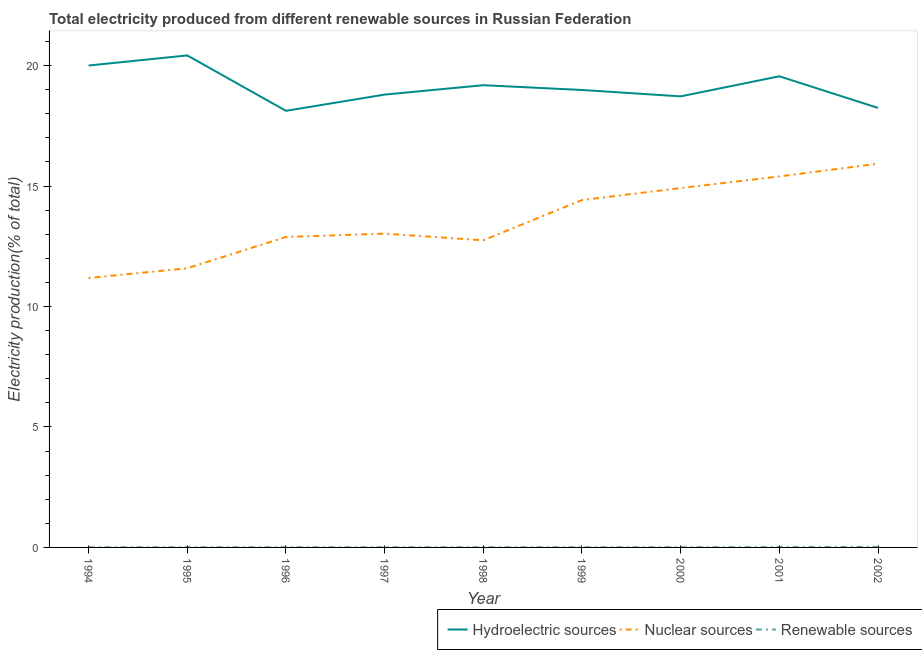How many different coloured lines are there?
Make the answer very short. 3. What is the percentage of electricity produced by nuclear sources in 1995?
Keep it short and to the point. 11.59. Across all years, what is the maximum percentage of electricity produced by renewable sources?
Provide a short and direct response. 0.02. Across all years, what is the minimum percentage of electricity produced by hydroelectric sources?
Your answer should be very brief. 18.12. In which year was the percentage of electricity produced by renewable sources maximum?
Your response must be concise. 2002. What is the total percentage of electricity produced by nuclear sources in the graph?
Keep it short and to the point. 122.08. What is the difference between the percentage of electricity produced by nuclear sources in 1998 and that in 1999?
Provide a short and direct response. -1.67. What is the difference between the percentage of electricity produced by renewable sources in 1995 and the percentage of electricity produced by nuclear sources in 2001?
Make the answer very short. -15.39. What is the average percentage of electricity produced by hydroelectric sources per year?
Make the answer very short. 19.11. In the year 1996, what is the difference between the percentage of electricity produced by renewable sources and percentage of electricity produced by nuclear sources?
Your response must be concise. -12.88. In how many years, is the percentage of electricity produced by renewable sources greater than 14 %?
Ensure brevity in your answer.  0. What is the ratio of the percentage of electricity produced by renewable sources in 1994 to that in 1996?
Your response must be concise. 1.04. What is the difference between the highest and the second highest percentage of electricity produced by nuclear sources?
Provide a short and direct response. 0.53. What is the difference between the highest and the lowest percentage of electricity produced by nuclear sources?
Offer a very short reply. 4.74. In how many years, is the percentage of electricity produced by renewable sources greater than the average percentage of electricity produced by renewable sources taken over all years?
Provide a succinct answer. 3. Is the sum of the percentage of electricity produced by renewable sources in 1996 and 2001 greater than the maximum percentage of electricity produced by nuclear sources across all years?
Give a very brief answer. No. Is the percentage of electricity produced by nuclear sources strictly greater than the percentage of electricity produced by renewable sources over the years?
Your response must be concise. Yes. How many lines are there?
Offer a terse response. 3. What is the difference between two consecutive major ticks on the Y-axis?
Your answer should be very brief. 5. Are the values on the major ticks of Y-axis written in scientific E-notation?
Provide a short and direct response. No. Does the graph contain any zero values?
Provide a succinct answer. No. How many legend labels are there?
Ensure brevity in your answer.  3. How are the legend labels stacked?
Your response must be concise. Horizontal. What is the title of the graph?
Keep it short and to the point. Total electricity produced from different renewable sources in Russian Federation. Does "Ages 20-50" appear as one of the legend labels in the graph?
Ensure brevity in your answer.  No. What is the Electricity production(% of total) of Hydroelectric sources in 1994?
Make the answer very short. 20. What is the Electricity production(% of total) of Nuclear sources in 1994?
Keep it short and to the point. 11.18. What is the Electricity production(% of total) in Renewable sources in 1994?
Your answer should be very brief. 0.01. What is the Electricity production(% of total) in Hydroelectric sources in 1995?
Provide a short and direct response. 20.42. What is the Electricity production(% of total) in Nuclear sources in 1995?
Offer a very short reply. 11.59. What is the Electricity production(% of total) of Renewable sources in 1995?
Keep it short and to the point. 0.01. What is the Electricity production(% of total) of Hydroelectric sources in 1996?
Keep it short and to the point. 18.12. What is the Electricity production(% of total) in Nuclear sources in 1996?
Your answer should be very brief. 12.88. What is the Electricity production(% of total) of Renewable sources in 1996?
Keep it short and to the point. 0.01. What is the Electricity production(% of total) in Hydroelectric sources in 1997?
Your answer should be very brief. 18.79. What is the Electricity production(% of total) in Nuclear sources in 1997?
Ensure brevity in your answer.  13.02. What is the Electricity production(% of total) in Renewable sources in 1997?
Provide a short and direct response. 0.01. What is the Electricity production(% of total) of Hydroelectric sources in 1998?
Ensure brevity in your answer.  19.18. What is the Electricity production(% of total) of Nuclear sources in 1998?
Your answer should be very brief. 12.75. What is the Electricity production(% of total) in Renewable sources in 1998?
Your answer should be very brief. 0.01. What is the Electricity production(% of total) of Hydroelectric sources in 1999?
Your response must be concise. 18.99. What is the Electricity production(% of total) in Nuclear sources in 1999?
Provide a succinct answer. 14.42. What is the Electricity production(% of total) in Renewable sources in 1999?
Offer a very short reply. 0.01. What is the Electricity production(% of total) in Hydroelectric sources in 2000?
Offer a terse response. 18.72. What is the Electricity production(% of total) of Nuclear sources in 2000?
Make the answer very short. 14.91. What is the Electricity production(% of total) in Renewable sources in 2000?
Give a very brief answer. 0.01. What is the Electricity production(% of total) in Hydroelectric sources in 2001?
Offer a very short reply. 19.55. What is the Electricity production(% of total) of Nuclear sources in 2001?
Offer a very short reply. 15.4. What is the Electricity production(% of total) of Renewable sources in 2001?
Give a very brief answer. 0.01. What is the Electricity production(% of total) in Hydroelectric sources in 2002?
Ensure brevity in your answer.  18.24. What is the Electricity production(% of total) in Nuclear sources in 2002?
Provide a short and direct response. 15.93. What is the Electricity production(% of total) of Renewable sources in 2002?
Offer a very short reply. 0.02. Across all years, what is the maximum Electricity production(% of total) in Hydroelectric sources?
Ensure brevity in your answer.  20.42. Across all years, what is the maximum Electricity production(% of total) of Nuclear sources?
Offer a terse response. 15.93. Across all years, what is the maximum Electricity production(% of total) in Renewable sources?
Keep it short and to the point. 0.02. Across all years, what is the minimum Electricity production(% of total) of Hydroelectric sources?
Keep it short and to the point. 18.12. Across all years, what is the minimum Electricity production(% of total) of Nuclear sources?
Your response must be concise. 11.18. Across all years, what is the minimum Electricity production(% of total) of Renewable sources?
Give a very brief answer. 0.01. What is the total Electricity production(% of total) of Hydroelectric sources in the graph?
Make the answer very short. 172.02. What is the total Electricity production(% of total) of Nuclear sources in the graph?
Your answer should be compact. 122.08. What is the total Electricity production(% of total) in Renewable sources in the graph?
Offer a terse response. 0.08. What is the difference between the Electricity production(% of total) in Hydroelectric sources in 1994 and that in 1995?
Provide a succinct answer. -0.42. What is the difference between the Electricity production(% of total) in Nuclear sources in 1994 and that in 1995?
Offer a very short reply. -0.41. What is the difference between the Electricity production(% of total) of Renewable sources in 1994 and that in 1995?
Your answer should be very brief. 0. What is the difference between the Electricity production(% of total) in Hydroelectric sources in 1994 and that in 1996?
Your response must be concise. 1.88. What is the difference between the Electricity production(% of total) of Nuclear sources in 1994 and that in 1996?
Ensure brevity in your answer.  -1.7. What is the difference between the Electricity production(% of total) of Renewable sources in 1994 and that in 1996?
Ensure brevity in your answer.  0. What is the difference between the Electricity production(% of total) in Hydroelectric sources in 1994 and that in 1997?
Provide a short and direct response. 1.21. What is the difference between the Electricity production(% of total) of Nuclear sources in 1994 and that in 1997?
Keep it short and to the point. -1.84. What is the difference between the Electricity production(% of total) of Hydroelectric sources in 1994 and that in 1998?
Keep it short and to the point. 0.82. What is the difference between the Electricity production(% of total) in Nuclear sources in 1994 and that in 1998?
Provide a succinct answer. -1.57. What is the difference between the Electricity production(% of total) of Renewable sources in 1994 and that in 1998?
Your answer should be very brief. -0. What is the difference between the Electricity production(% of total) of Hydroelectric sources in 1994 and that in 1999?
Your response must be concise. 1.01. What is the difference between the Electricity production(% of total) of Nuclear sources in 1994 and that in 1999?
Your answer should be compact. -3.24. What is the difference between the Electricity production(% of total) in Renewable sources in 1994 and that in 1999?
Your answer should be compact. -0. What is the difference between the Electricity production(% of total) in Hydroelectric sources in 1994 and that in 2000?
Your response must be concise. 1.28. What is the difference between the Electricity production(% of total) in Nuclear sources in 1994 and that in 2000?
Provide a succinct answer. -3.73. What is the difference between the Electricity production(% of total) in Renewable sources in 1994 and that in 2000?
Ensure brevity in your answer.  -0. What is the difference between the Electricity production(% of total) of Hydroelectric sources in 1994 and that in 2001?
Ensure brevity in your answer.  0.45. What is the difference between the Electricity production(% of total) of Nuclear sources in 1994 and that in 2001?
Offer a terse response. -4.22. What is the difference between the Electricity production(% of total) in Renewable sources in 1994 and that in 2001?
Provide a succinct answer. -0.01. What is the difference between the Electricity production(% of total) in Hydroelectric sources in 1994 and that in 2002?
Your answer should be very brief. 1.76. What is the difference between the Electricity production(% of total) of Nuclear sources in 1994 and that in 2002?
Offer a very short reply. -4.74. What is the difference between the Electricity production(% of total) of Renewable sources in 1994 and that in 2002?
Provide a succinct answer. -0.01. What is the difference between the Electricity production(% of total) of Hydroelectric sources in 1995 and that in 1996?
Offer a terse response. 2.3. What is the difference between the Electricity production(% of total) of Nuclear sources in 1995 and that in 1996?
Provide a short and direct response. -1.3. What is the difference between the Electricity production(% of total) of Renewable sources in 1995 and that in 1996?
Offer a very short reply. 0. What is the difference between the Electricity production(% of total) in Hydroelectric sources in 1995 and that in 1997?
Ensure brevity in your answer.  1.63. What is the difference between the Electricity production(% of total) in Nuclear sources in 1995 and that in 1997?
Provide a succinct answer. -1.44. What is the difference between the Electricity production(% of total) of Renewable sources in 1995 and that in 1997?
Give a very brief answer. 0. What is the difference between the Electricity production(% of total) of Hydroelectric sources in 1995 and that in 1998?
Your answer should be compact. 1.24. What is the difference between the Electricity production(% of total) of Nuclear sources in 1995 and that in 1998?
Offer a terse response. -1.16. What is the difference between the Electricity production(% of total) of Renewable sources in 1995 and that in 1998?
Provide a succinct answer. -0. What is the difference between the Electricity production(% of total) in Hydroelectric sources in 1995 and that in 1999?
Provide a succinct answer. 1.43. What is the difference between the Electricity production(% of total) in Nuclear sources in 1995 and that in 1999?
Your answer should be very brief. -2.83. What is the difference between the Electricity production(% of total) of Renewable sources in 1995 and that in 1999?
Provide a short and direct response. -0. What is the difference between the Electricity production(% of total) in Hydroelectric sources in 1995 and that in 2000?
Make the answer very short. 1.7. What is the difference between the Electricity production(% of total) in Nuclear sources in 1995 and that in 2000?
Ensure brevity in your answer.  -3.33. What is the difference between the Electricity production(% of total) of Renewable sources in 1995 and that in 2000?
Offer a terse response. -0. What is the difference between the Electricity production(% of total) in Hydroelectric sources in 1995 and that in 2001?
Make the answer very short. 0.87. What is the difference between the Electricity production(% of total) of Nuclear sources in 1995 and that in 2001?
Make the answer very short. -3.81. What is the difference between the Electricity production(% of total) of Renewable sources in 1995 and that in 2001?
Offer a terse response. -0.01. What is the difference between the Electricity production(% of total) in Hydroelectric sources in 1995 and that in 2002?
Provide a short and direct response. 2.18. What is the difference between the Electricity production(% of total) in Nuclear sources in 1995 and that in 2002?
Give a very brief answer. -4.34. What is the difference between the Electricity production(% of total) in Renewable sources in 1995 and that in 2002?
Ensure brevity in your answer.  -0.01. What is the difference between the Electricity production(% of total) in Hydroelectric sources in 1996 and that in 1997?
Provide a succinct answer. -0.67. What is the difference between the Electricity production(% of total) in Nuclear sources in 1996 and that in 1997?
Your answer should be very brief. -0.14. What is the difference between the Electricity production(% of total) in Renewable sources in 1996 and that in 1997?
Give a very brief answer. -0. What is the difference between the Electricity production(% of total) of Hydroelectric sources in 1996 and that in 1998?
Ensure brevity in your answer.  -1.06. What is the difference between the Electricity production(% of total) in Nuclear sources in 1996 and that in 1998?
Ensure brevity in your answer.  0.14. What is the difference between the Electricity production(% of total) of Renewable sources in 1996 and that in 1998?
Your response must be concise. -0. What is the difference between the Electricity production(% of total) of Hydroelectric sources in 1996 and that in 1999?
Provide a short and direct response. -0.86. What is the difference between the Electricity production(% of total) in Nuclear sources in 1996 and that in 1999?
Give a very brief answer. -1.53. What is the difference between the Electricity production(% of total) of Renewable sources in 1996 and that in 1999?
Provide a succinct answer. -0. What is the difference between the Electricity production(% of total) of Hydroelectric sources in 1996 and that in 2000?
Offer a very short reply. -0.6. What is the difference between the Electricity production(% of total) of Nuclear sources in 1996 and that in 2000?
Give a very brief answer. -2.03. What is the difference between the Electricity production(% of total) of Renewable sources in 1996 and that in 2000?
Offer a very short reply. -0. What is the difference between the Electricity production(% of total) in Hydroelectric sources in 1996 and that in 2001?
Make the answer very short. -1.43. What is the difference between the Electricity production(% of total) in Nuclear sources in 1996 and that in 2001?
Your answer should be compact. -2.51. What is the difference between the Electricity production(% of total) of Renewable sources in 1996 and that in 2001?
Your response must be concise. -0.01. What is the difference between the Electricity production(% of total) of Hydroelectric sources in 1996 and that in 2002?
Offer a very short reply. -0.12. What is the difference between the Electricity production(% of total) in Nuclear sources in 1996 and that in 2002?
Give a very brief answer. -3.04. What is the difference between the Electricity production(% of total) of Renewable sources in 1996 and that in 2002?
Make the answer very short. -0.01. What is the difference between the Electricity production(% of total) in Hydroelectric sources in 1997 and that in 1998?
Provide a short and direct response. -0.39. What is the difference between the Electricity production(% of total) in Nuclear sources in 1997 and that in 1998?
Make the answer very short. 0.27. What is the difference between the Electricity production(% of total) in Renewable sources in 1997 and that in 1998?
Provide a succinct answer. -0. What is the difference between the Electricity production(% of total) in Hydroelectric sources in 1997 and that in 1999?
Your answer should be very brief. -0.19. What is the difference between the Electricity production(% of total) in Nuclear sources in 1997 and that in 1999?
Provide a succinct answer. -1.39. What is the difference between the Electricity production(% of total) in Renewable sources in 1997 and that in 1999?
Make the answer very short. -0. What is the difference between the Electricity production(% of total) of Hydroelectric sources in 1997 and that in 2000?
Offer a terse response. 0.07. What is the difference between the Electricity production(% of total) in Nuclear sources in 1997 and that in 2000?
Provide a succinct answer. -1.89. What is the difference between the Electricity production(% of total) in Renewable sources in 1997 and that in 2000?
Your answer should be compact. -0. What is the difference between the Electricity production(% of total) of Hydroelectric sources in 1997 and that in 2001?
Offer a terse response. -0.76. What is the difference between the Electricity production(% of total) of Nuclear sources in 1997 and that in 2001?
Your response must be concise. -2.38. What is the difference between the Electricity production(% of total) in Renewable sources in 1997 and that in 2001?
Give a very brief answer. -0.01. What is the difference between the Electricity production(% of total) of Hydroelectric sources in 1997 and that in 2002?
Provide a succinct answer. 0.55. What is the difference between the Electricity production(% of total) in Nuclear sources in 1997 and that in 2002?
Give a very brief answer. -2.9. What is the difference between the Electricity production(% of total) of Renewable sources in 1997 and that in 2002?
Your response must be concise. -0.01. What is the difference between the Electricity production(% of total) in Hydroelectric sources in 1998 and that in 1999?
Provide a succinct answer. 0.2. What is the difference between the Electricity production(% of total) in Nuclear sources in 1998 and that in 1999?
Make the answer very short. -1.67. What is the difference between the Electricity production(% of total) in Renewable sources in 1998 and that in 1999?
Ensure brevity in your answer.  -0. What is the difference between the Electricity production(% of total) in Hydroelectric sources in 1998 and that in 2000?
Offer a very short reply. 0.46. What is the difference between the Electricity production(% of total) of Nuclear sources in 1998 and that in 2000?
Your answer should be compact. -2.17. What is the difference between the Electricity production(% of total) of Renewable sources in 1998 and that in 2000?
Keep it short and to the point. -0. What is the difference between the Electricity production(% of total) in Hydroelectric sources in 1998 and that in 2001?
Offer a very short reply. -0.37. What is the difference between the Electricity production(% of total) of Nuclear sources in 1998 and that in 2001?
Make the answer very short. -2.65. What is the difference between the Electricity production(% of total) in Renewable sources in 1998 and that in 2001?
Provide a succinct answer. -0.01. What is the difference between the Electricity production(% of total) of Hydroelectric sources in 1998 and that in 2002?
Keep it short and to the point. 0.94. What is the difference between the Electricity production(% of total) in Nuclear sources in 1998 and that in 2002?
Offer a terse response. -3.18. What is the difference between the Electricity production(% of total) of Renewable sources in 1998 and that in 2002?
Your answer should be compact. -0.01. What is the difference between the Electricity production(% of total) in Hydroelectric sources in 1999 and that in 2000?
Your answer should be compact. 0.27. What is the difference between the Electricity production(% of total) of Nuclear sources in 1999 and that in 2000?
Offer a very short reply. -0.5. What is the difference between the Electricity production(% of total) of Renewable sources in 1999 and that in 2000?
Give a very brief answer. -0. What is the difference between the Electricity production(% of total) in Hydroelectric sources in 1999 and that in 2001?
Make the answer very short. -0.57. What is the difference between the Electricity production(% of total) in Nuclear sources in 1999 and that in 2001?
Offer a very short reply. -0.98. What is the difference between the Electricity production(% of total) in Renewable sources in 1999 and that in 2001?
Your response must be concise. -0.01. What is the difference between the Electricity production(% of total) in Hydroelectric sources in 1999 and that in 2002?
Offer a terse response. 0.74. What is the difference between the Electricity production(% of total) of Nuclear sources in 1999 and that in 2002?
Ensure brevity in your answer.  -1.51. What is the difference between the Electricity production(% of total) of Renewable sources in 1999 and that in 2002?
Offer a terse response. -0.01. What is the difference between the Electricity production(% of total) in Hydroelectric sources in 2000 and that in 2001?
Offer a very short reply. -0.83. What is the difference between the Electricity production(% of total) of Nuclear sources in 2000 and that in 2001?
Offer a very short reply. -0.48. What is the difference between the Electricity production(% of total) of Renewable sources in 2000 and that in 2001?
Your answer should be very brief. -0. What is the difference between the Electricity production(% of total) in Hydroelectric sources in 2000 and that in 2002?
Give a very brief answer. 0.48. What is the difference between the Electricity production(% of total) of Nuclear sources in 2000 and that in 2002?
Offer a terse response. -1.01. What is the difference between the Electricity production(% of total) of Renewable sources in 2000 and that in 2002?
Give a very brief answer. -0.01. What is the difference between the Electricity production(% of total) of Hydroelectric sources in 2001 and that in 2002?
Keep it short and to the point. 1.31. What is the difference between the Electricity production(% of total) in Nuclear sources in 2001 and that in 2002?
Offer a very short reply. -0.53. What is the difference between the Electricity production(% of total) in Renewable sources in 2001 and that in 2002?
Make the answer very short. -0.01. What is the difference between the Electricity production(% of total) of Hydroelectric sources in 1994 and the Electricity production(% of total) of Nuclear sources in 1995?
Provide a short and direct response. 8.41. What is the difference between the Electricity production(% of total) in Hydroelectric sources in 1994 and the Electricity production(% of total) in Renewable sources in 1995?
Give a very brief answer. 19.99. What is the difference between the Electricity production(% of total) of Nuclear sources in 1994 and the Electricity production(% of total) of Renewable sources in 1995?
Your response must be concise. 11.17. What is the difference between the Electricity production(% of total) of Hydroelectric sources in 1994 and the Electricity production(% of total) of Nuclear sources in 1996?
Ensure brevity in your answer.  7.12. What is the difference between the Electricity production(% of total) of Hydroelectric sources in 1994 and the Electricity production(% of total) of Renewable sources in 1996?
Offer a very short reply. 19.99. What is the difference between the Electricity production(% of total) of Nuclear sources in 1994 and the Electricity production(% of total) of Renewable sources in 1996?
Your answer should be very brief. 11.17. What is the difference between the Electricity production(% of total) in Hydroelectric sources in 1994 and the Electricity production(% of total) in Nuclear sources in 1997?
Ensure brevity in your answer.  6.98. What is the difference between the Electricity production(% of total) of Hydroelectric sources in 1994 and the Electricity production(% of total) of Renewable sources in 1997?
Keep it short and to the point. 19.99. What is the difference between the Electricity production(% of total) of Nuclear sources in 1994 and the Electricity production(% of total) of Renewable sources in 1997?
Make the answer very short. 11.17. What is the difference between the Electricity production(% of total) of Hydroelectric sources in 1994 and the Electricity production(% of total) of Nuclear sources in 1998?
Offer a terse response. 7.25. What is the difference between the Electricity production(% of total) of Hydroelectric sources in 1994 and the Electricity production(% of total) of Renewable sources in 1998?
Provide a short and direct response. 19.99. What is the difference between the Electricity production(% of total) of Nuclear sources in 1994 and the Electricity production(% of total) of Renewable sources in 1998?
Ensure brevity in your answer.  11.17. What is the difference between the Electricity production(% of total) in Hydroelectric sources in 1994 and the Electricity production(% of total) in Nuclear sources in 1999?
Ensure brevity in your answer.  5.58. What is the difference between the Electricity production(% of total) of Hydroelectric sources in 1994 and the Electricity production(% of total) of Renewable sources in 1999?
Your answer should be compact. 19.99. What is the difference between the Electricity production(% of total) in Nuclear sources in 1994 and the Electricity production(% of total) in Renewable sources in 1999?
Ensure brevity in your answer.  11.17. What is the difference between the Electricity production(% of total) in Hydroelectric sources in 1994 and the Electricity production(% of total) in Nuclear sources in 2000?
Provide a succinct answer. 5.09. What is the difference between the Electricity production(% of total) in Hydroelectric sources in 1994 and the Electricity production(% of total) in Renewable sources in 2000?
Your response must be concise. 19.99. What is the difference between the Electricity production(% of total) of Nuclear sources in 1994 and the Electricity production(% of total) of Renewable sources in 2000?
Provide a succinct answer. 11.17. What is the difference between the Electricity production(% of total) of Hydroelectric sources in 1994 and the Electricity production(% of total) of Nuclear sources in 2001?
Offer a terse response. 4.6. What is the difference between the Electricity production(% of total) in Hydroelectric sources in 1994 and the Electricity production(% of total) in Renewable sources in 2001?
Your answer should be compact. 19.99. What is the difference between the Electricity production(% of total) in Nuclear sources in 1994 and the Electricity production(% of total) in Renewable sources in 2001?
Give a very brief answer. 11.17. What is the difference between the Electricity production(% of total) of Hydroelectric sources in 1994 and the Electricity production(% of total) of Nuclear sources in 2002?
Provide a succinct answer. 4.07. What is the difference between the Electricity production(% of total) in Hydroelectric sources in 1994 and the Electricity production(% of total) in Renewable sources in 2002?
Provide a short and direct response. 19.98. What is the difference between the Electricity production(% of total) of Nuclear sources in 1994 and the Electricity production(% of total) of Renewable sources in 2002?
Give a very brief answer. 11.16. What is the difference between the Electricity production(% of total) in Hydroelectric sources in 1995 and the Electricity production(% of total) in Nuclear sources in 1996?
Provide a short and direct response. 7.54. What is the difference between the Electricity production(% of total) in Hydroelectric sources in 1995 and the Electricity production(% of total) in Renewable sources in 1996?
Offer a very short reply. 20.41. What is the difference between the Electricity production(% of total) in Nuclear sources in 1995 and the Electricity production(% of total) in Renewable sources in 1996?
Offer a very short reply. 11.58. What is the difference between the Electricity production(% of total) in Hydroelectric sources in 1995 and the Electricity production(% of total) in Nuclear sources in 1997?
Your answer should be very brief. 7.4. What is the difference between the Electricity production(% of total) of Hydroelectric sources in 1995 and the Electricity production(% of total) of Renewable sources in 1997?
Provide a succinct answer. 20.41. What is the difference between the Electricity production(% of total) of Nuclear sources in 1995 and the Electricity production(% of total) of Renewable sources in 1997?
Your answer should be compact. 11.58. What is the difference between the Electricity production(% of total) of Hydroelectric sources in 1995 and the Electricity production(% of total) of Nuclear sources in 1998?
Provide a short and direct response. 7.67. What is the difference between the Electricity production(% of total) in Hydroelectric sources in 1995 and the Electricity production(% of total) in Renewable sources in 1998?
Provide a short and direct response. 20.41. What is the difference between the Electricity production(% of total) of Nuclear sources in 1995 and the Electricity production(% of total) of Renewable sources in 1998?
Ensure brevity in your answer.  11.58. What is the difference between the Electricity production(% of total) in Hydroelectric sources in 1995 and the Electricity production(% of total) in Nuclear sources in 1999?
Offer a terse response. 6. What is the difference between the Electricity production(% of total) in Hydroelectric sources in 1995 and the Electricity production(% of total) in Renewable sources in 1999?
Offer a very short reply. 20.41. What is the difference between the Electricity production(% of total) of Nuclear sources in 1995 and the Electricity production(% of total) of Renewable sources in 1999?
Keep it short and to the point. 11.58. What is the difference between the Electricity production(% of total) in Hydroelectric sources in 1995 and the Electricity production(% of total) in Nuclear sources in 2000?
Give a very brief answer. 5.51. What is the difference between the Electricity production(% of total) in Hydroelectric sources in 1995 and the Electricity production(% of total) in Renewable sources in 2000?
Offer a terse response. 20.41. What is the difference between the Electricity production(% of total) in Nuclear sources in 1995 and the Electricity production(% of total) in Renewable sources in 2000?
Ensure brevity in your answer.  11.58. What is the difference between the Electricity production(% of total) in Hydroelectric sources in 1995 and the Electricity production(% of total) in Nuclear sources in 2001?
Give a very brief answer. 5.02. What is the difference between the Electricity production(% of total) in Hydroelectric sources in 1995 and the Electricity production(% of total) in Renewable sources in 2001?
Offer a very short reply. 20.41. What is the difference between the Electricity production(% of total) in Nuclear sources in 1995 and the Electricity production(% of total) in Renewable sources in 2001?
Your answer should be compact. 11.57. What is the difference between the Electricity production(% of total) in Hydroelectric sources in 1995 and the Electricity production(% of total) in Nuclear sources in 2002?
Offer a terse response. 4.49. What is the difference between the Electricity production(% of total) of Hydroelectric sources in 1995 and the Electricity production(% of total) of Renewable sources in 2002?
Provide a short and direct response. 20.4. What is the difference between the Electricity production(% of total) in Nuclear sources in 1995 and the Electricity production(% of total) in Renewable sources in 2002?
Offer a terse response. 11.57. What is the difference between the Electricity production(% of total) in Hydroelectric sources in 1996 and the Electricity production(% of total) in Nuclear sources in 1997?
Your answer should be very brief. 5.1. What is the difference between the Electricity production(% of total) of Hydroelectric sources in 1996 and the Electricity production(% of total) of Renewable sources in 1997?
Keep it short and to the point. 18.11. What is the difference between the Electricity production(% of total) of Nuclear sources in 1996 and the Electricity production(% of total) of Renewable sources in 1997?
Your response must be concise. 12.88. What is the difference between the Electricity production(% of total) in Hydroelectric sources in 1996 and the Electricity production(% of total) in Nuclear sources in 1998?
Your answer should be very brief. 5.37. What is the difference between the Electricity production(% of total) of Hydroelectric sources in 1996 and the Electricity production(% of total) of Renewable sources in 1998?
Your response must be concise. 18.11. What is the difference between the Electricity production(% of total) in Nuclear sources in 1996 and the Electricity production(% of total) in Renewable sources in 1998?
Offer a very short reply. 12.88. What is the difference between the Electricity production(% of total) of Hydroelectric sources in 1996 and the Electricity production(% of total) of Nuclear sources in 1999?
Your response must be concise. 3.7. What is the difference between the Electricity production(% of total) of Hydroelectric sources in 1996 and the Electricity production(% of total) of Renewable sources in 1999?
Give a very brief answer. 18.11. What is the difference between the Electricity production(% of total) in Nuclear sources in 1996 and the Electricity production(% of total) in Renewable sources in 1999?
Keep it short and to the point. 12.88. What is the difference between the Electricity production(% of total) in Hydroelectric sources in 1996 and the Electricity production(% of total) in Nuclear sources in 2000?
Your response must be concise. 3.21. What is the difference between the Electricity production(% of total) in Hydroelectric sources in 1996 and the Electricity production(% of total) in Renewable sources in 2000?
Offer a terse response. 18.11. What is the difference between the Electricity production(% of total) of Nuclear sources in 1996 and the Electricity production(% of total) of Renewable sources in 2000?
Your answer should be very brief. 12.88. What is the difference between the Electricity production(% of total) of Hydroelectric sources in 1996 and the Electricity production(% of total) of Nuclear sources in 2001?
Your response must be concise. 2.72. What is the difference between the Electricity production(% of total) in Hydroelectric sources in 1996 and the Electricity production(% of total) in Renewable sources in 2001?
Give a very brief answer. 18.11. What is the difference between the Electricity production(% of total) in Nuclear sources in 1996 and the Electricity production(% of total) in Renewable sources in 2001?
Keep it short and to the point. 12.87. What is the difference between the Electricity production(% of total) in Hydroelectric sources in 1996 and the Electricity production(% of total) in Nuclear sources in 2002?
Give a very brief answer. 2.19. What is the difference between the Electricity production(% of total) in Hydroelectric sources in 1996 and the Electricity production(% of total) in Renewable sources in 2002?
Make the answer very short. 18.1. What is the difference between the Electricity production(% of total) in Nuclear sources in 1996 and the Electricity production(% of total) in Renewable sources in 2002?
Ensure brevity in your answer.  12.86. What is the difference between the Electricity production(% of total) in Hydroelectric sources in 1997 and the Electricity production(% of total) in Nuclear sources in 1998?
Your answer should be very brief. 6.05. What is the difference between the Electricity production(% of total) of Hydroelectric sources in 1997 and the Electricity production(% of total) of Renewable sources in 1998?
Offer a very short reply. 18.79. What is the difference between the Electricity production(% of total) in Nuclear sources in 1997 and the Electricity production(% of total) in Renewable sources in 1998?
Your response must be concise. 13.02. What is the difference between the Electricity production(% of total) in Hydroelectric sources in 1997 and the Electricity production(% of total) in Nuclear sources in 1999?
Provide a short and direct response. 4.38. What is the difference between the Electricity production(% of total) in Hydroelectric sources in 1997 and the Electricity production(% of total) in Renewable sources in 1999?
Your answer should be compact. 18.79. What is the difference between the Electricity production(% of total) of Nuclear sources in 1997 and the Electricity production(% of total) of Renewable sources in 1999?
Provide a succinct answer. 13.02. What is the difference between the Electricity production(% of total) in Hydroelectric sources in 1997 and the Electricity production(% of total) in Nuclear sources in 2000?
Make the answer very short. 3.88. What is the difference between the Electricity production(% of total) in Hydroelectric sources in 1997 and the Electricity production(% of total) in Renewable sources in 2000?
Your response must be concise. 18.78. What is the difference between the Electricity production(% of total) in Nuclear sources in 1997 and the Electricity production(% of total) in Renewable sources in 2000?
Your answer should be very brief. 13.01. What is the difference between the Electricity production(% of total) of Hydroelectric sources in 1997 and the Electricity production(% of total) of Nuclear sources in 2001?
Offer a terse response. 3.4. What is the difference between the Electricity production(% of total) of Hydroelectric sources in 1997 and the Electricity production(% of total) of Renewable sources in 2001?
Offer a very short reply. 18.78. What is the difference between the Electricity production(% of total) in Nuclear sources in 1997 and the Electricity production(% of total) in Renewable sources in 2001?
Offer a terse response. 13.01. What is the difference between the Electricity production(% of total) in Hydroelectric sources in 1997 and the Electricity production(% of total) in Nuclear sources in 2002?
Offer a terse response. 2.87. What is the difference between the Electricity production(% of total) in Hydroelectric sources in 1997 and the Electricity production(% of total) in Renewable sources in 2002?
Your answer should be very brief. 18.77. What is the difference between the Electricity production(% of total) of Nuclear sources in 1997 and the Electricity production(% of total) of Renewable sources in 2002?
Your response must be concise. 13. What is the difference between the Electricity production(% of total) in Hydroelectric sources in 1998 and the Electricity production(% of total) in Nuclear sources in 1999?
Provide a short and direct response. 4.77. What is the difference between the Electricity production(% of total) in Hydroelectric sources in 1998 and the Electricity production(% of total) in Renewable sources in 1999?
Offer a terse response. 19.18. What is the difference between the Electricity production(% of total) in Nuclear sources in 1998 and the Electricity production(% of total) in Renewable sources in 1999?
Your response must be concise. 12.74. What is the difference between the Electricity production(% of total) in Hydroelectric sources in 1998 and the Electricity production(% of total) in Nuclear sources in 2000?
Provide a short and direct response. 4.27. What is the difference between the Electricity production(% of total) of Hydroelectric sources in 1998 and the Electricity production(% of total) of Renewable sources in 2000?
Your answer should be compact. 19.17. What is the difference between the Electricity production(% of total) of Nuclear sources in 1998 and the Electricity production(% of total) of Renewable sources in 2000?
Offer a very short reply. 12.74. What is the difference between the Electricity production(% of total) of Hydroelectric sources in 1998 and the Electricity production(% of total) of Nuclear sources in 2001?
Provide a short and direct response. 3.79. What is the difference between the Electricity production(% of total) of Hydroelectric sources in 1998 and the Electricity production(% of total) of Renewable sources in 2001?
Your response must be concise. 19.17. What is the difference between the Electricity production(% of total) in Nuclear sources in 1998 and the Electricity production(% of total) in Renewable sources in 2001?
Your answer should be compact. 12.73. What is the difference between the Electricity production(% of total) in Hydroelectric sources in 1998 and the Electricity production(% of total) in Nuclear sources in 2002?
Offer a terse response. 3.26. What is the difference between the Electricity production(% of total) in Hydroelectric sources in 1998 and the Electricity production(% of total) in Renewable sources in 2002?
Provide a short and direct response. 19.16. What is the difference between the Electricity production(% of total) in Nuclear sources in 1998 and the Electricity production(% of total) in Renewable sources in 2002?
Offer a very short reply. 12.73. What is the difference between the Electricity production(% of total) in Hydroelectric sources in 1999 and the Electricity production(% of total) in Nuclear sources in 2000?
Provide a succinct answer. 4.07. What is the difference between the Electricity production(% of total) in Hydroelectric sources in 1999 and the Electricity production(% of total) in Renewable sources in 2000?
Give a very brief answer. 18.98. What is the difference between the Electricity production(% of total) of Nuclear sources in 1999 and the Electricity production(% of total) of Renewable sources in 2000?
Your answer should be very brief. 14.41. What is the difference between the Electricity production(% of total) of Hydroelectric sources in 1999 and the Electricity production(% of total) of Nuclear sources in 2001?
Provide a short and direct response. 3.59. What is the difference between the Electricity production(% of total) in Hydroelectric sources in 1999 and the Electricity production(% of total) in Renewable sources in 2001?
Offer a terse response. 18.97. What is the difference between the Electricity production(% of total) in Nuclear sources in 1999 and the Electricity production(% of total) in Renewable sources in 2001?
Give a very brief answer. 14.4. What is the difference between the Electricity production(% of total) in Hydroelectric sources in 1999 and the Electricity production(% of total) in Nuclear sources in 2002?
Your response must be concise. 3.06. What is the difference between the Electricity production(% of total) in Hydroelectric sources in 1999 and the Electricity production(% of total) in Renewable sources in 2002?
Make the answer very short. 18.97. What is the difference between the Electricity production(% of total) of Nuclear sources in 1999 and the Electricity production(% of total) of Renewable sources in 2002?
Provide a succinct answer. 14.4. What is the difference between the Electricity production(% of total) of Hydroelectric sources in 2000 and the Electricity production(% of total) of Nuclear sources in 2001?
Give a very brief answer. 3.32. What is the difference between the Electricity production(% of total) of Hydroelectric sources in 2000 and the Electricity production(% of total) of Renewable sources in 2001?
Your response must be concise. 18.71. What is the difference between the Electricity production(% of total) in Nuclear sources in 2000 and the Electricity production(% of total) in Renewable sources in 2001?
Offer a terse response. 14.9. What is the difference between the Electricity production(% of total) of Hydroelectric sources in 2000 and the Electricity production(% of total) of Nuclear sources in 2002?
Provide a short and direct response. 2.79. What is the difference between the Electricity production(% of total) of Hydroelectric sources in 2000 and the Electricity production(% of total) of Renewable sources in 2002?
Offer a terse response. 18.7. What is the difference between the Electricity production(% of total) in Nuclear sources in 2000 and the Electricity production(% of total) in Renewable sources in 2002?
Make the answer very short. 14.89. What is the difference between the Electricity production(% of total) of Hydroelectric sources in 2001 and the Electricity production(% of total) of Nuclear sources in 2002?
Make the answer very short. 3.63. What is the difference between the Electricity production(% of total) in Hydroelectric sources in 2001 and the Electricity production(% of total) in Renewable sources in 2002?
Keep it short and to the point. 19.53. What is the difference between the Electricity production(% of total) in Nuclear sources in 2001 and the Electricity production(% of total) in Renewable sources in 2002?
Your answer should be compact. 15.38. What is the average Electricity production(% of total) of Hydroelectric sources per year?
Offer a very short reply. 19.11. What is the average Electricity production(% of total) in Nuclear sources per year?
Offer a terse response. 13.56. What is the average Electricity production(% of total) of Renewable sources per year?
Your answer should be very brief. 0.01. In the year 1994, what is the difference between the Electricity production(% of total) of Hydroelectric sources and Electricity production(% of total) of Nuclear sources?
Your answer should be compact. 8.82. In the year 1994, what is the difference between the Electricity production(% of total) in Hydroelectric sources and Electricity production(% of total) in Renewable sources?
Offer a terse response. 19.99. In the year 1994, what is the difference between the Electricity production(% of total) of Nuclear sources and Electricity production(% of total) of Renewable sources?
Provide a short and direct response. 11.17. In the year 1995, what is the difference between the Electricity production(% of total) of Hydroelectric sources and Electricity production(% of total) of Nuclear sources?
Ensure brevity in your answer.  8.83. In the year 1995, what is the difference between the Electricity production(% of total) of Hydroelectric sources and Electricity production(% of total) of Renewable sources?
Your answer should be compact. 20.41. In the year 1995, what is the difference between the Electricity production(% of total) in Nuclear sources and Electricity production(% of total) in Renewable sources?
Provide a short and direct response. 11.58. In the year 1996, what is the difference between the Electricity production(% of total) in Hydroelectric sources and Electricity production(% of total) in Nuclear sources?
Give a very brief answer. 5.24. In the year 1996, what is the difference between the Electricity production(% of total) in Hydroelectric sources and Electricity production(% of total) in Renewable sources?
Keep it short and to the point. 18.11. In the year 1996, what is the difference between the Electricity production(% of total) in Nuclear sources and Electricity production(% of total) in Renewable sources?
Your answer should be compact. 12.88. In the year 1997, what is the difference between the Electricity production(% of total) of Hydroelectric sources and Electricity production(% of total) of Nuclear sources?
Your response must be concise. 5.77. In the year 1997, what is the difference between the Electricity production(% of total) in Hydroelectric sources and Electricity production(% of total) in Renewable sources?
Offer a very short reply. 18.79. In the year 1997, what is the difference between the Electricity production(% of total) of Nuclear sources and Electricity production(% of total) of Renewable sources?
Keep it short and to the point. 13.02. In the year 1998, what is the difference between the Electricity production(% of total) of Hydroelectric sources and Electricity production(% of total) of Nuclear sources?
Your response must be concise. 6.44. In the year 1998, what is the difference between the Electricity production(% of total) in Hydroelectric sources and Electricity production(% of total) in Renewable sources?
Keep it short and to the point. 19.18. In the year 1998, what is the difference between the Electricity production(% of total) of Nuclear sources and Electricity production(% of total) of Renewable sources?
Give a very brief answer. 12.74. In the year 1999, what is the difference between the Electricity production(% of total) of Hydroelectric sources and Electricity production(% of total) of Nuclear sources?
Your answer should be compact. 4.57. In the year 1999, what is the difference between the Electricity production(% of total) in Hydroelectric sources and Electricity production(% of total) in Renewable sources?
Your answer should be very brief. 18.98. In the year 1999, what is the difference between the Electricity production(% of total) of Nuclear sources and Electricity production(% of total) of Renewable sources?
Your answer should be compact. 14.41. In the year 2000, what is the difference between the Electricity production(% of total) of Hydroelectric sources and Electricity production(% of total) of Nuclear sources?
Offer a terse response. 3.81. In the year 2000, what is the difference between the Electricity production(% of total) of Hydroelectric sources and Electricity production(% of total) of Renewable sources?
Make the answer very short. 18.71. In the year 2000, what is the difference between the Electricity production(% of total) in Nuclear sources and Electricity production(% of total) in Renewable sources?
Provide a succinct answer. 14.9. In the year 2001, what is the difference between the Electricity production(% of total) in Hydroelectric sources and Electricity production(% of total) in Nuclear sources?
Keep it short and to the point. 4.16. In the year 2001, what is the difference between the Electricity production(% of total) of Hydroelectric sources and Electricity production(% of total) of Renewable sources?
Your answer should be compact. 19.54. In the year 2001, what is the difference between the Electricity production(% of total) of Nuclear sources and Electricity production(% of total) of Renewable sources?
Offer a terse response. 15.38. In the year 2002, what is the difference between the Electricity production(% of total) of Hydroelectric sources and Electricity production(% of total) of Nuclear sources?
Provide a succinct answer. 2.31. In the year 2002, what is the difference between the Electricity production(% of total) in Hydroelectric sources and Electricity production(% of total) in Renewable sources?
Your answer should be compact. 18.22. In the year 2002, what is the difference between the Electricity production(% of total) in Nuclear sources and Electricity production(% of total) in Renewable sources?
Your response must be concise. 15.91. What is the ratio of the Electricity production(% of total) of Hydroelectric sources in 1994 to that in 1995?
Offer a very short reply. 0.98. What is the ratio of the Electricity production(% of total) in Renewable sources in 1994 to that in 1995?
Your answer should be very brief. 1.02. What is the ratio of the Electricity production(% of total) in Hydroelectric sources in 1994 to that in 1996?
Offer a terse response. 1.1. What is the ratio of the Electricity production(% of total) in Nuclear sources in 1994 to that in 1996?
Provide a short and direct response. 0.87. What is the ratio of the Electricity production(% of total) in Renewable sources in 1994 to that in 1996?
Give a very brief answer. 1.04. What is the ratio of the Electricity production(% of total) of Hydroelectric sources in 1994 to that in 1997?
Offer a terse response. 1.06. What is the ratio of the Electricity production(% of total) of Nuclear sources in 1994 to that in 1997?
Your response must be concise. 0.86. What is the ratio of the Electricity production(% of total) of Renewable sources in 1994 to that in 1997?
Ensure brevity in your answer.  1.02. What is the ratio of the Electricity production(% of total) of Hydroelectric sources in 1994 to that in 1998?
Provide a succinct answer. 1.04. What is the ratio of the Electricity production(% of total) of Nuclear sources in 1994 to that in 1998?
Ensure brevity in your answer.  0.88. What is the ratio of the Electricity production(% of total) of Renewable sources in 1994 to that in 1998?
Give a very brief answer. 0.99. What is the ratio of the Electricity production(% of total) of Hydroelectric sources in 1994 to that in 1999?
Ensure brevity in your answer.  1.05. What is the ratio of the Electricity production(% of total) of Nuclear sources in 1994 to that in 1999?
Your answer should be very brief. 0.78. What is the ratio of the Electricity production(% of total) of Renewable sources in 1994 to that in 1999?
Ensure brevity in your answer.  0.98. What is the ratio of the Electricity production(% of total) of Hydroelectric sources in 1994 to that in 2000?
Offer a terse response. 1.07. What is the ratio of the Electricity production(% of total) of Nuclear sources in 1994 to that in 2000?
Provide a succinct answer. 0.75. What is the ratio of the Electricity production(% of total) in Renewable sources in 1994 to that in 2000?
Keep it short and to the point. 0.75. What is the ratio of the Electricity production(% of total) of Hydroelectric sources in 1994 to that in 2001?
Ensure brevity in your answer.  1.02. What is the ratio of the Electricity production(% of total) of Nuclear sources in 1994 to that in 2001?
Ensure brevity in your answer.  0.73. What is the ratio of the Electricity production(% of total) of Renewable sources in 1994 to that in 2001?
Your answer should be very brief. 0.53. What is the ratio of the Electricity production(% of total) in Hydroelectric sources in 1994 to that in 2002?
Your answer should be compact. 1.1. What is the ratio of the Electricity production(% of total) in Nuclear sources in 1994 to that in 2002?
Give a very brief answer. 0.7. What is the ratio of the Electricity production(% of total) in Renewable sources in 1994 to that in 2002?
Make the answer very short. 0.35. What is the ratio of the Electricity production(% of total) in Hydroelectric sources in 1995 to that in 1996?
Keep it short and to the point. 1.13. What is the ratio of the Electricity production(% of total) in Nuclear sources in 1995 to that in 1996?
Your response must be concise. 0.9. What is the ratio of the Electricity production(% of total) of Renewable sources in 1995 to that in 1996?
Provide a succinct answer. 1.02. What is the ratio of the Electricity production(% of total) of Hydroelectric sources in 1995 to that in 1997?
Your answer should be compact. 1.09. What is the ratio of the Electricity production(% of total) of Nuclear sources in 1995 to that in 1997?
Offer a terse response. 0.89. What is the ratio of the Electricity production(% of total) in Renewable sources in 1995 to that in 1997?
Provide a succinct answer. 1. What is the ratio of the Electricity production(% of total) in Hydroelectric sources in 1995 to that in 1998?
Offer a terse response. 1.06. What is the ratio of the Electricity production(% of total) in Nuclear sources in 1995 to that in 1998?
Offer a very short reply. 0.91. What is the ratio of the Electricity production(% of total) of Renewable sources in 1995 to that in 1998?
Keep it short and to the point. 0.98. What is the ratio of the Electricity production(% of total) of Hydroelectric sources in 1995 to that in 1999?
Your response must be concise. 1.08. What is the ratio of the Electricity production(% of total) of Nuclear sources in 1995 to that in 1999?
Your response must be concise. 0.8. What is the ratio of the Electricity production(% of total) of Hydroelectric sources in 1995 to that in 2000?
Provide a short and direct response. 1.09. What is the ratio of the Electricity production(% of total) of Nuclear sources in 1995 to that in 2000?
Your answer should be very brief. 0.78. What is the ratio of the Electricity production(% of total) in Renewable sources in 1995 to that in 2000?
Your answer should be very brief. 0.73. What is the ratio of the Electricity production(% of total) in Hydroelectric sources in 1995 to that in 2001?
Your response must be concise. 1.04. What is the ratio of the Electricity production(% of total) in Nuclear sources in 1995 to that in 2001?
Your answer should be very brief. 0.75. What is the ratio of the Electricity production(% of total) in Renewable sources in 1995 to that in 2001?
Your response must be concise. 0.52. What is the ratio of the Electricity production(% of total) of Hydroelectric sources in 1995 to that in 2002?
Provide a short and direct response. 1.12. What is the ratio of the Electricity production(% of total) in Nuclear sources in 1995 to that in 2002?
Make the answer very short. 0.73. What is the ratio of the Electricity production(% of total) in Renewable sources in 1995 to that in 2002?
Your answer should be compact. 0.34. What is the ratio of the Electricity production(% of total) of Hydroelectric sources in 1996 to that in 1997?
Make the answer very short. 0.96. What is the ratio of the Electricity production(% of total) in Renewable sources in 1996 to that in 1997?
Your answer should be very brief. 0.98. What is the ratio of the Electricity production(% of total) of Hydroelectric sources in 1996 to that in 1998?
Ensure brevity in your answer.  0.94. What is the ratio of the Electricity production(% of total) of Nuclear sources in 1996 to that in 1998?
Give a very brief answer. 1.01. What is the ratio of the Electricity production(% of total) of Renewable sources in 1996 to that in 1998?
Your response must be concise. 0.96. What is the ratio of the Electricity production(% of total) of Hydroelectric sources in 1996 to that in 1999?
Give a very brief answer. 0.95. What is the ratio of the Electricity production(% of total) of Nuclear sources in 1996 to that in 1999?
Offer a terse response. 0.89. What is the ratio of the Electricity production(% of total) in Renewable sources in 1996 to that in 1999?
Ensure brevity in your answer.  0.95. What is the ratio of the Electricity production(% of total) in Hydroelectric sources in 1996 to that in 2000?
Offer a terse response. 0.97. What is the ratio of the Electricity production(% of total) in Nuclear sources in 1996 to that in 2000?
Keep it short and to the point. 0.86. What is the ratio of the Electricity production(% of total) in Renewable sources in 1996 to that in 2000?
Give a very brief answer. 0.72. What is the ratio of the Electricity production(% of total) in Hydroelectric sources in 1996 to that in 2001?
Provide a short and direct response. 0.93. What is the ratio of the Electricity production(% of total) in Nuclear sources in 1996 to that in 2001?
Ensure brevity in your answer.  0.84. What is the ratio of the Electricity production(% of total) of Renewable sources in 1996 to that in 2001?
Keep it short and to the point. 0.51. What is the ratio of the Electricity production(% of total) of Hydroelectric sources in 1996 to that in 2002?
Give a very brief answer. 0.99. What is the ratio of the Electricity production(% of total) in Nuclear sources in 1996 to that in 2002?
Keep it short and to the point. 0.81. What is the ratio of the Electricity production(% of total) of Renewable sources in 1996 to that in 2002?
Offer a terse response. 0.33. What is the ratio of the Electricity production(% of total) of Hydroelectric sources in 1997 to that in 1998?
Your response must be concise. 0.98. What is the ratio of the Electricity production(% of total) in Nuclear sources in 1997 to that in 1998?
Your response must be concise. 1.02. What is the ratio of the Electricity production(% of total) of Renewable sources in 1997 to that in 1998?
Your answer should be very brief. 0.97. What is the ratio of the Electricity production(% of total) in Nuclear sources in 1997 to that in 1999?
Your answer should be very brief. 0.9. What is the ratio of the Electricity production(% of total) in Renewable sources in 1997 to that in 1999?
Your answer should be compact. 0.96. What is the ratio of the Electricity production(% of total) in Hydroelectric sources in 1997 to that in 2000?
Provide a short and direct response. 1. What is the ratio of the Electricity production(% of total) in Nuclear sources in 1997 to that in 2000?
Offer a very short reply. 0.87. What is the ratio of the Electricity production(% of total) of Renewable sources in 1997 to that in 2000?
Keep it short and to the point. 0.73. What is the ratio of the Electricity production(% of total) of Hydroelectric sources in 1997 to that in 2001?
Offer a terse response. 0.96. What is the ratio of the Electricity production(% of total) in Nuclear sources in 1997 to that in 2001?
Provide a succinct answer. 0.85. What is the ratio of the Electricity production(% of total) of Renewable sources in 1997 to that in 2001?
Give a very brief answer. 0.52. What is the ratio of the Electricity production(% of total) in Hydroelectric sources in 1997 to that in 2002?
Give a very brief answer. 1.03. What is the ratio of the Electricity production(% of total) of Nuclear sources in 1997 to that in 2002?
Provide a short and direct response. 0.82. What is the ratio of the Electricity production(% of total) of Renewable sources in 1997 to that in 2002?
Ensure brevity in your answer.  0.34. What is the ratio of the Electricity production(% of total) of Hydroelectric sources in 1998 to that in 1999?
Ensure brevity in your answer.  1.01. What is the ratio of the Electricity production(% of total) in Nuclear sources in 1998 to that in 1999?
Offer a terse response. 0.88. What is the ratio of the Electricity production(% of total) in Renewable sources in 1998 to that in 1999?
Keep it short and to the point. 0.99. What is the ratio of the Electricity production(% of total) of Hydroelectric sources in 1998 to that in 2000?
Offer a terse response. 1.02. What is the ratio of the Electricity production(% of total) in Nuclear sources in 1998 to that in 2000?
Ensure brevity in your answer.  0.85. What is the ratio of the Electricity production(% of total) in Renewable sources in 1998 to that in 2000?
Your response must be concise. 0.75. What is the ratio of the Electricity production(% of total) of Hydroelectric sources in 1998 to that in 2001?
Ensure brevity in your answer.  0.98. What is the ratio of the Electricity production(% of total) of Nuclear sources in 1998 to that in 2001?
Offer a terse response. 0.83. What is the ratio of the Electricity production(% of total) in Renewable sources in 1998 to that in 2001?
Offer a very short reply. 0.53. What is the ratio of the Electricity production(% of total) in Hydroelectric sources in 1998 to that in 2002?
Ensure brevity in your answer.  1.05. What is the ratio of the Electricity production(% of total) of Nuclear sources in 1998 to that in 2002?
Make the answer very short. 0.8. What is the ratio of the Electricity production(% of total) of Renewable sources in 1998 to that in 2002?
Make the answer very short. 0.35. What is the ratio of the Electricity production(% of total) in Hydroelectric sources in 1999 to that in 2000?
Offer a very short reply. 1.01. What is the ratio of the Electricity production(% of total) of Nuclear sources in 1999 to that in 2000?
Ensure brevity in your answer.  0.97. What is the ratio of the Electricity production(% of total) in Renewable sources in 1999 to that in 2000?
Offer a very short reply. 0.76. What is the ratio of the Electricity production(% of total) in Hydroelectric sources in 1999 to that in 2001?
Ensure brevity in your answer.  0.97. What is the ratio of the Electricity production(% of total) in Nuclear sources in 1999 to that in 2001?
Your response must be concise. 0.94. What is the ratio of the Electricity production(% of total) of Renewable sources in 1999 to that in 2001?
Give a very brief answer. 0.54. What is the ratio of the Electricity production(% of total) of Hydroelectric sources in 1999 to that in 2002?
Your response must be concise. 1.04. What is the ratio of the Electricity production(% of total) in Nuclear sources in 1999 to that in 2002?
Offer a terse response. 0.91. What is the ratio of the Electricity production(% of total) of Renewable sources in 1999 to that in 2002?
Give a very brief answer. 0.35. What is the ratio of the Electricity production(% of total) in Hydroelectric sources in 2000 to that in 2001?
Ensure brevity in your answer.  0.96. What is the ratio of the Electricity production(% of total) of Nuclear sources in 2000 to that in 2001?
Provide a short and direct response. 0.97. What is the ratio of the Electricity production(% of total) of Renewable sources in 2000 to that in 2001?
Your answer should be very brief. 0.71. What is the ratio of the Electricity production(% of total) of Hydroelectric sources in 2000 to that in 2002?
Provide a short and direct response. 1.03. What is the ratio of the Electricity production(% of total) of Nuclear sources in 2000 to that in 2002?
Offer a terse response. 0.94. What is the ratio of the Electricity production(% of total) of Renewable sources in 2000 to that in 2002?
Make the answer very short. 0.46. What is the ratio of the Electricity production(% of total) in Hydroelectric sources in 2001 to that in 2002?
Provide a succinct answer. 1.07. What is the ratio of the Electricity production(% of total) of Nuclear sources in 2001 to that in 2002?
Your response must be concise. 0.97. What is the ratio of the Electricity production(% of total) of Renewable sources in 2001 to that in 2002?
Your response must be concise. 0.65. What is the difference between the highest and the second highest Electricity production(% of total) in Hydroelectric sources?
Offer a very short reply. 0.42. What is the difference between the highest and the second highest Electricity production(% of total) in Nuclear sources?
Provide a succinct answer. 0.53. What is the difference between the highest and the second highest Electricity production(% of total) in Renewable sources?
Your answer should be compact. 0.01. What is the difference between the highest and the lowest Electricity production(% of total) in Hydroelectric sources?
Your answer should be very brief. 2.3. What is the difference between the highest and the lowest Electricity production(% of total) in Nuclear sources?
Provide a succinct answer. 4.74. What is the difference between the highest and the lowest Electricity production(% of total) in Renewable sources?
Your response must be concise. 0.01. 